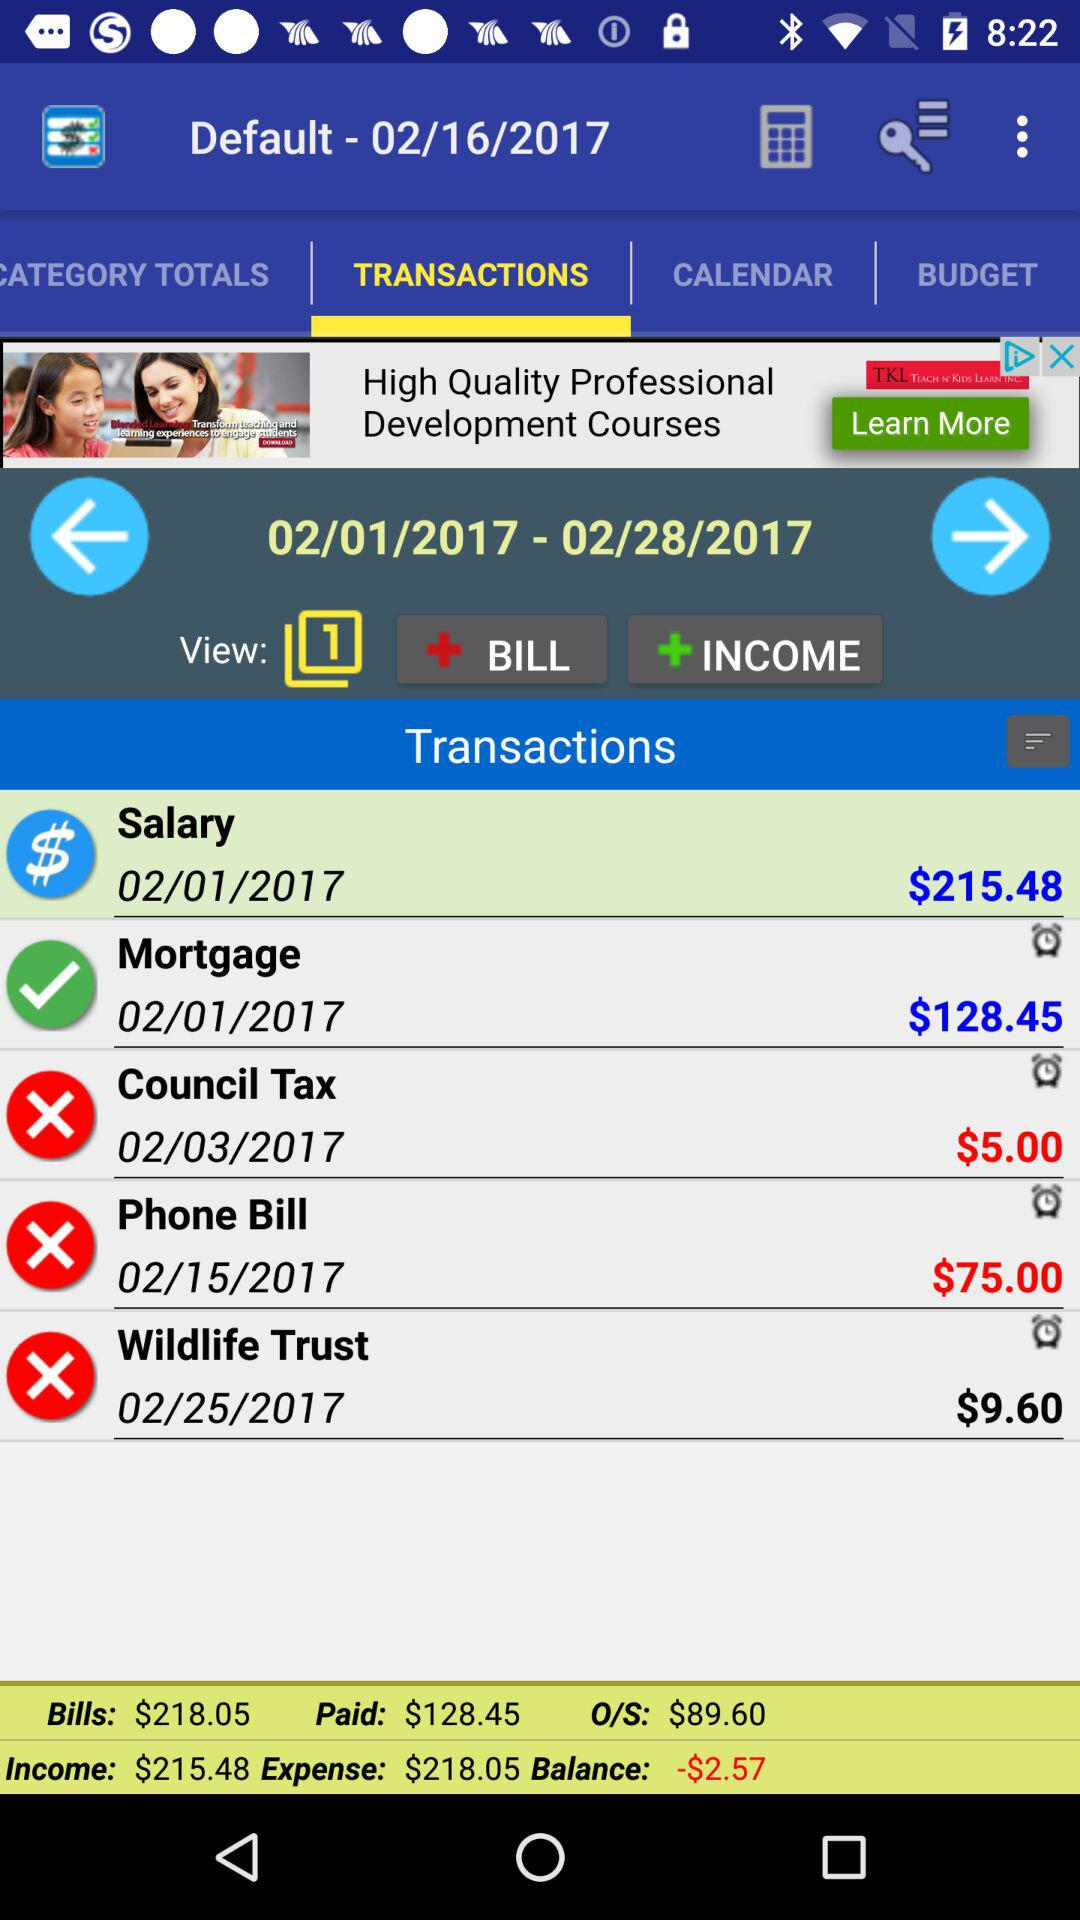How much is the shown balance? The shown balance is -$2.57. 